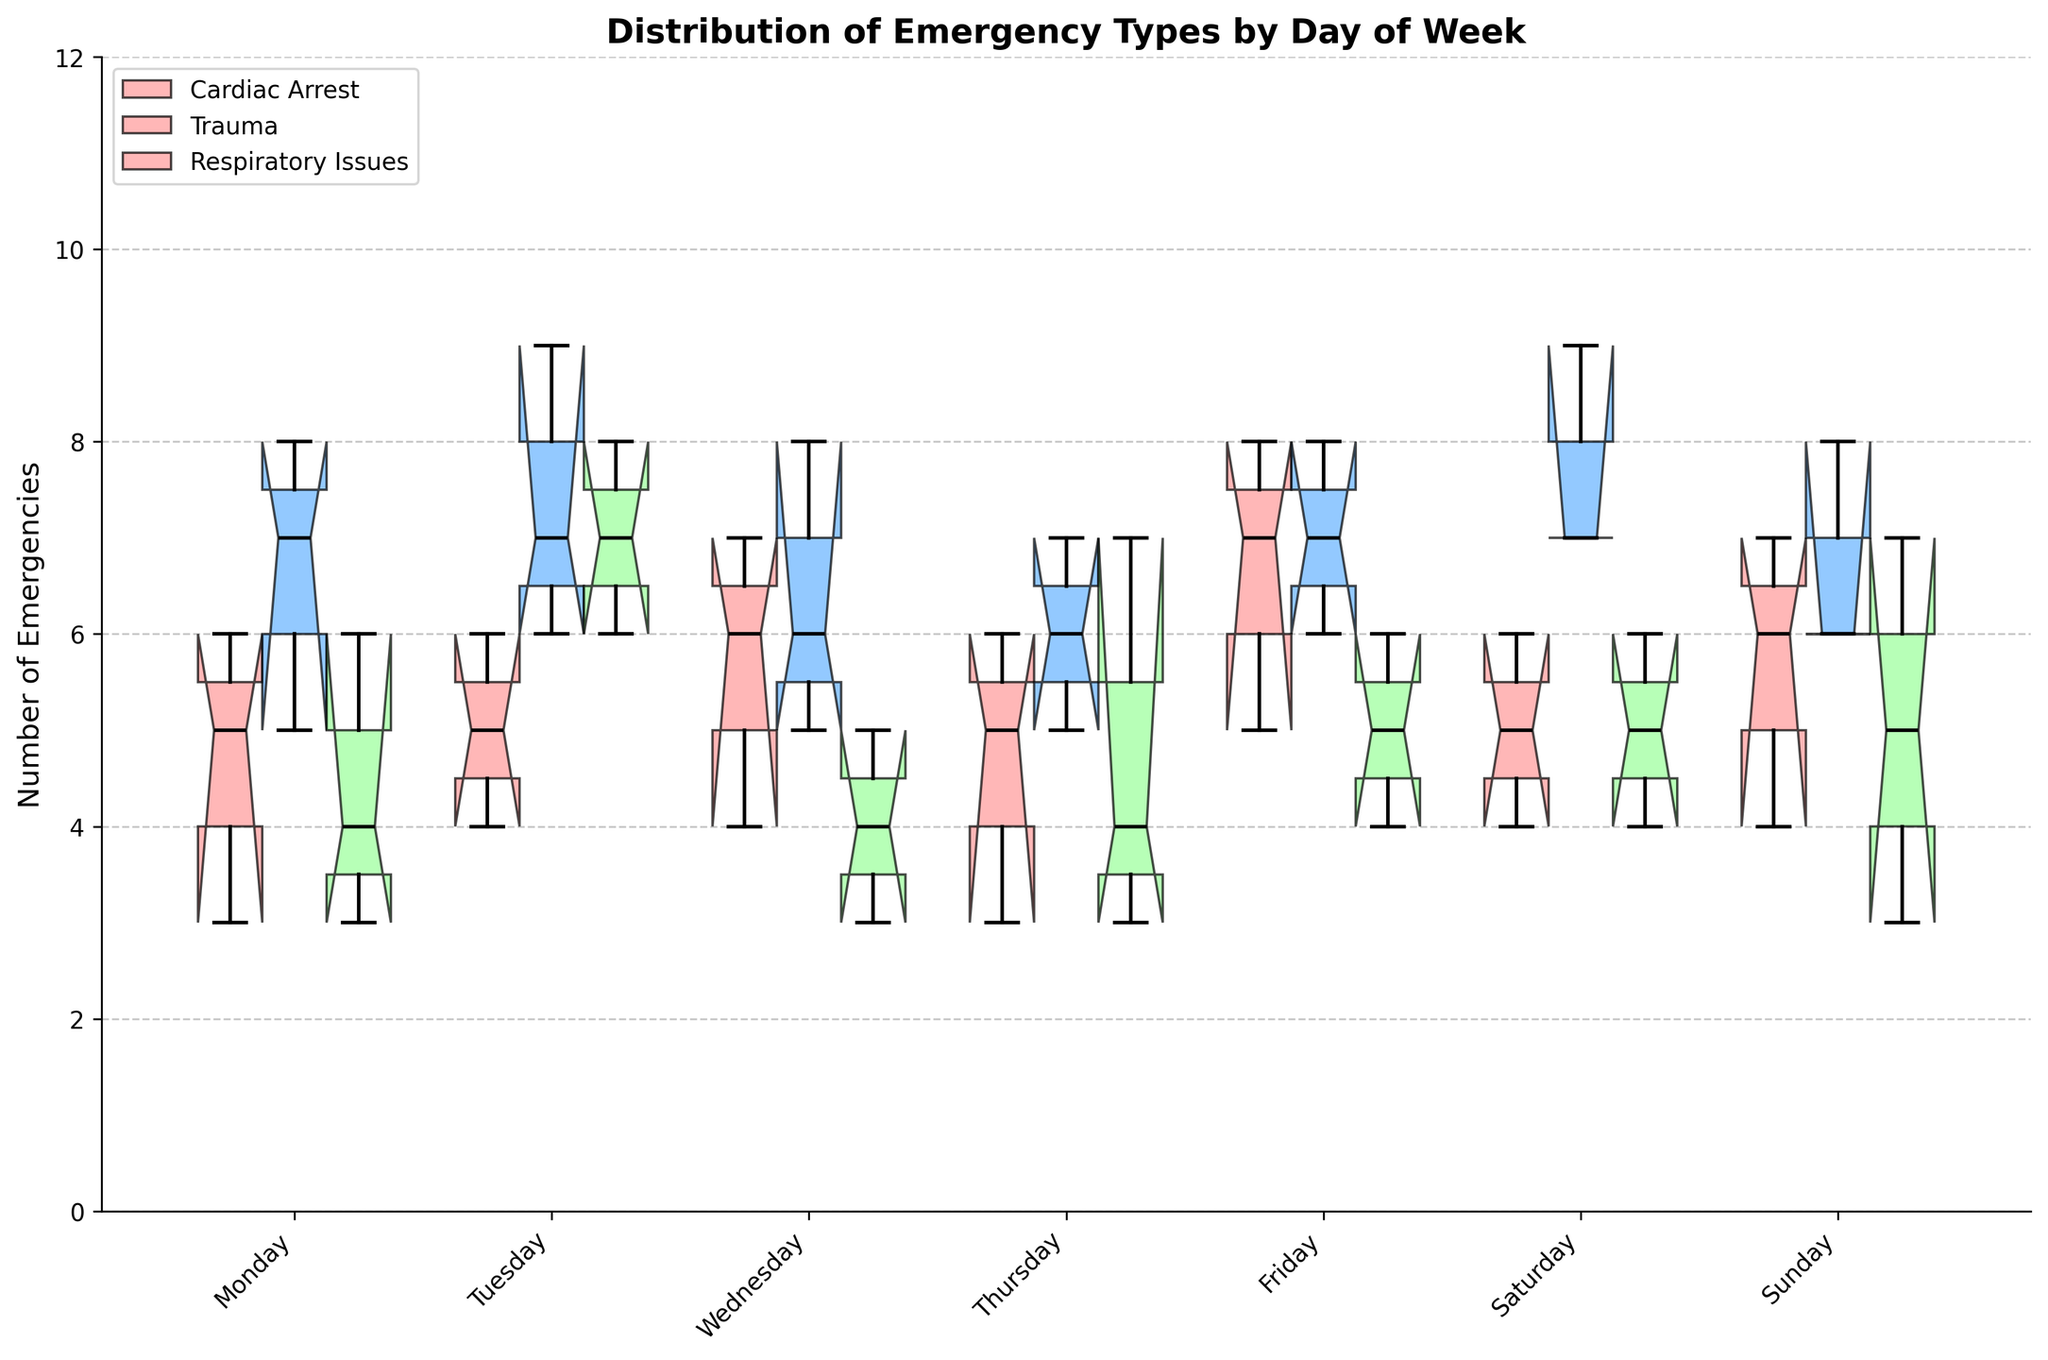What is the title of the figure? The title of the figure is displayed at the top. By reading it, we can understand that the title summarizes the main content of the figure.
Answer: Distribution of Emergency Types by Day of Week What does the y-axis represent? You can see that the y-axis has a label along the vertical side of the figure. This label indicates what the y-axis measures.
Answer: Number of Emergencies What color represents Trauma emergencies on the plot? The legend at the upper left corner of the plot provides information about which color corresponds to each emergency type. Look for the label "Trauma" and note its color.
Answer: Blue Which day has the highest median number of cardiac arrests? Inspect the notched box plots for "Cardiac Arrest" across all days of the week. The median is indicated by the horizontal black line within each box. Compare these lines to determine the highest median.
Answer: Friday On which day do respiratory issues show the widest interquartile range (IQR)? For "Respiratory Issues", examine the vertical length of the boxes, as the IQR is the range between the upper and lower quartiles (top and bottom of the boxes). Identify the box with the widest span.
Answer: Tuesday What is the median number of emergencies for Trauma on Friday? Look for the box plot corresponding to "Trauma" on Friday. The median value is represented by the black horizontal line inside the box. Read off this value.
Answer: 7 Comparing Monday and Saturday, on which day do cardiac arrests have fewer outliers? Examine the box plots for "Cardiac Arrest" on Monday and Saturday. Outliers are usually marked as individual points outside the whiskers. Count and compare the outliers on both days.
Answer: Saturday Which emergency type has the highest variability in counts on any single day, and on which day? Variability can be inferred from the lengths of the whiskers and presence of outliers. Look for the box plot with the longest whiskers and/or most outliers. Note the emergency type and the day this occurs.
Answer: Trauma on Saturday How does the median count of Trauma emergencies compare between Monday and Wednesday? Compare the median lines (horizontal black lines) within the "Trauma" box plots for Monday and Wednesday. Note which median is higher.
Answer: Monday Is there a day when all three types of emergencies have a similar range in counts? A similar range means the boxes (IQR) and whiskers span roughly the same length. Visually inspect and compare the ranges (IQR and whiskers) across all three emergency types for each day.
Answer: Wednesday 